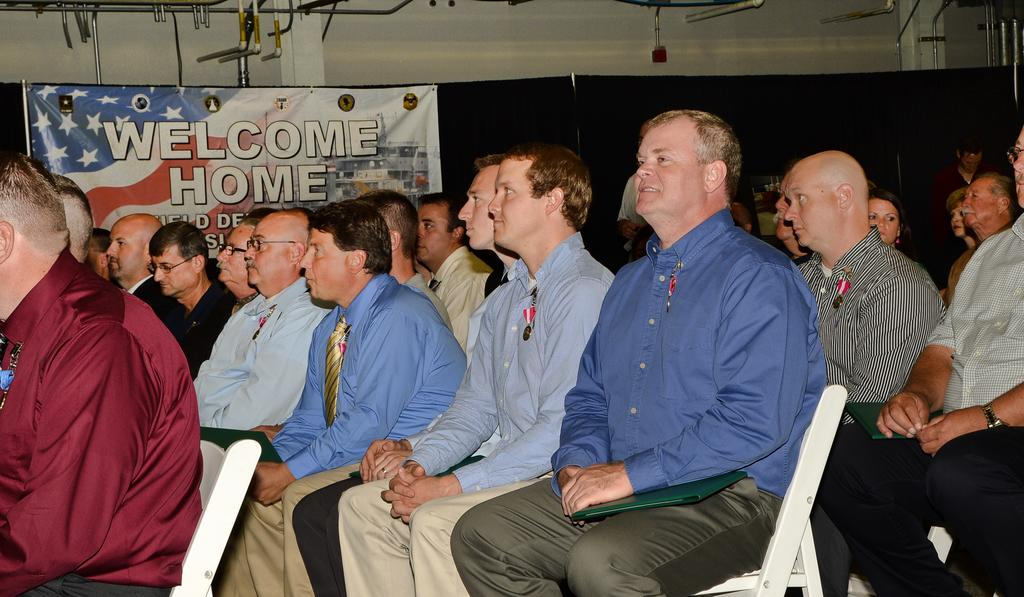What is the man in the image sitting on? The man is sitting on a white chair. What is the man wearing in the image? The man is wearing a blue shirt. Are there other people in the image? Yes, there are other men sitting on chairs in the image. What can be seen on the left side of the image? There is a banner on the left side of the image. Can you see any cherries on the man's shirt in the image? No, there are no cherries visible on the man's shirt in the image. Is there a rose growing on the chair the man is sitting on? No, there is no rose present on the chair or anywhere else in the image. 